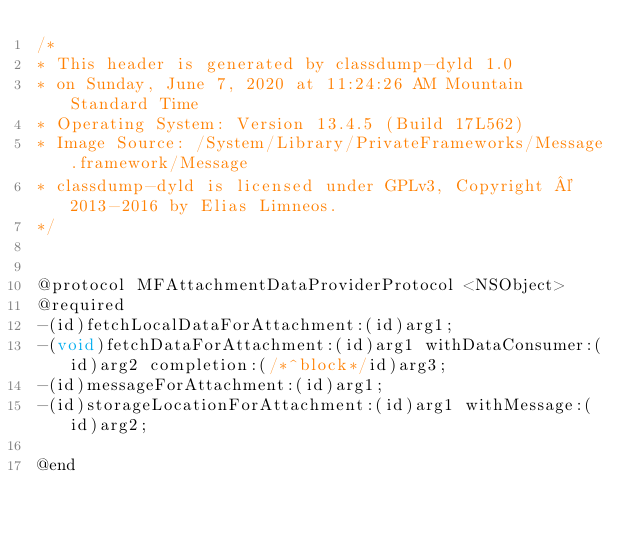<code> <loc_0><loc_0><loc_500><loc_500><_C_>/*
* This header is generated by classdump-dyld 1.0
* on Sunday, June 7, 2020 at 11:24:26 AM Mountain Standard Time
* Operating System: Version 13.4.5 (Build 17L562)
* Image Source: /System/Library/PrivateFrameworks/Message.framework/Message
* classdump-dyld is licensed under GPLv3, Copyright © 2013-2016 by Elias Limneos.
*/


@protocol MFAttachmentDataProviderProtocol <NSObject>
@required
-(id)fetchLocalDataForAttachment:(id)arg1;
-(void)fetchDataForAttachment:(id)arg1 withDataConsumer:(id)arg2 completion:(/*^block*/id)arg3;
-(id)messageForAttachment:(id)arg1;
-(id)storageLocationForAttachment:(id)arg1 withMessage:(id)arg2;

@end

</code> 